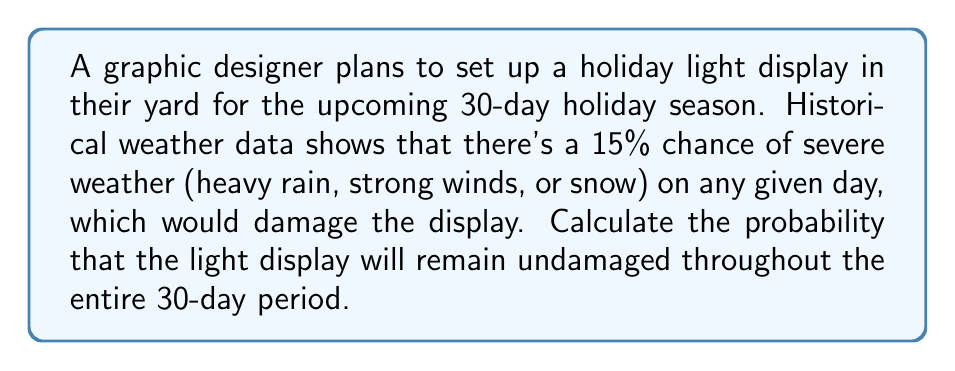Show me your answer to this math problem. Let's approach this step-by-step:

1) First, we need to calculate the probability of the display surviving one day. This is the opposite of the probability of damage occurring:

   $P(\text{survive one day}) = 1 - P(\text{damage}) = 1 - 0.15 = 0.85$

2) Now, for the display to remain undamaged for the entire 30-day period, it needs to survive each day independently. This is a case of independent events occurring in succession.

3) The probability of independent events all occurring is the product of their individual probabilities. In this case, we have the same probability (0.85) occurring 30 times:

   $P(\text{survive 30 days}) = (0.85)^{30}$

4) Let's calculate this:

   $$(0.85)^{30} = 0.00803...$$

5) To express this as a percentage, we multiply by 100:

   $$0.00803... \times 100 \approx 0.803\%$$

Therefore, there's approximately a 0.803% chance that the light display will remain undamaged for the entire 30-day holiday season.
Answer: $0.803\%$ 